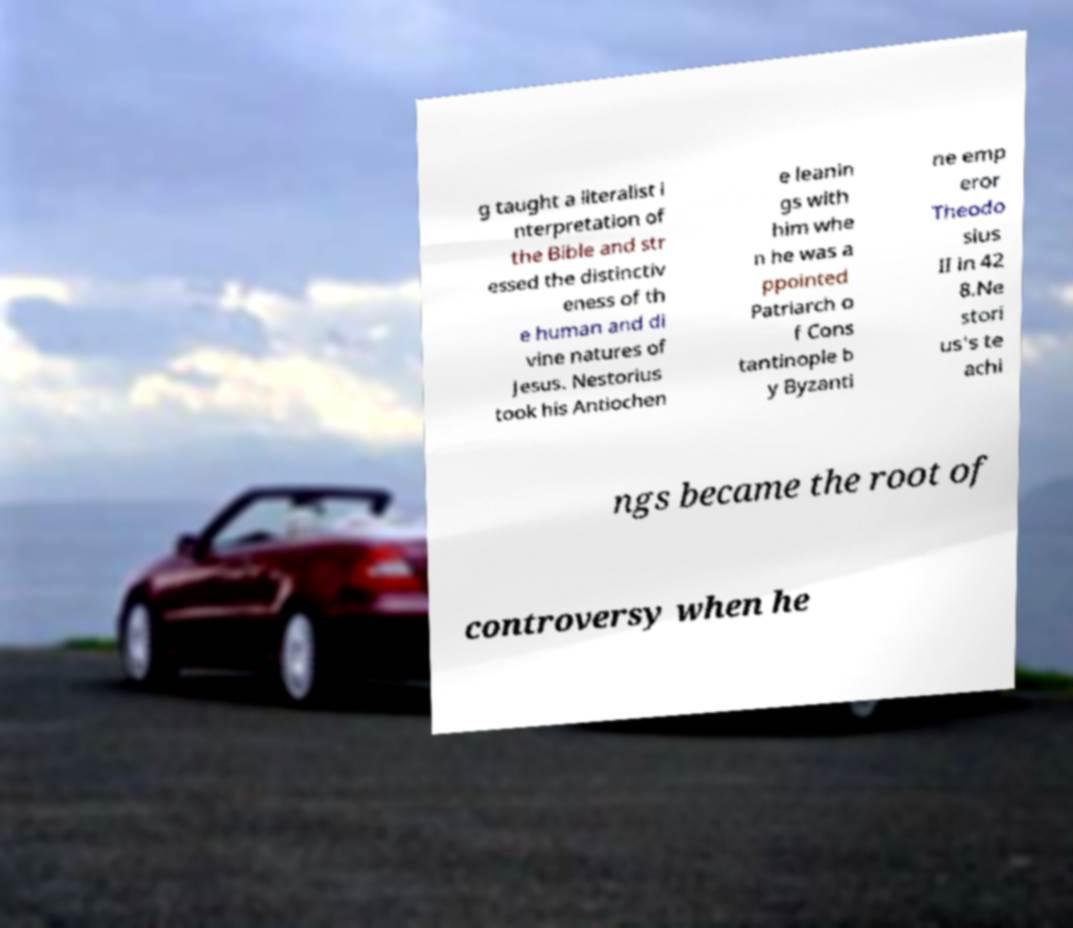Could you extract and type out the text from this image? g taught a literalist i nterpretation of the Bible and str essed the distinctiv eness of th e human and di vine natures of Jesus. Nestorius took his Antiochen e leanin gs with him whe n he was a ppointed Patriarch o f Cons tantinople b y Byzanti ne emp eror Theodo sius II in 42 8.Ne stori us's te achi ngs became the root of controversy when he 